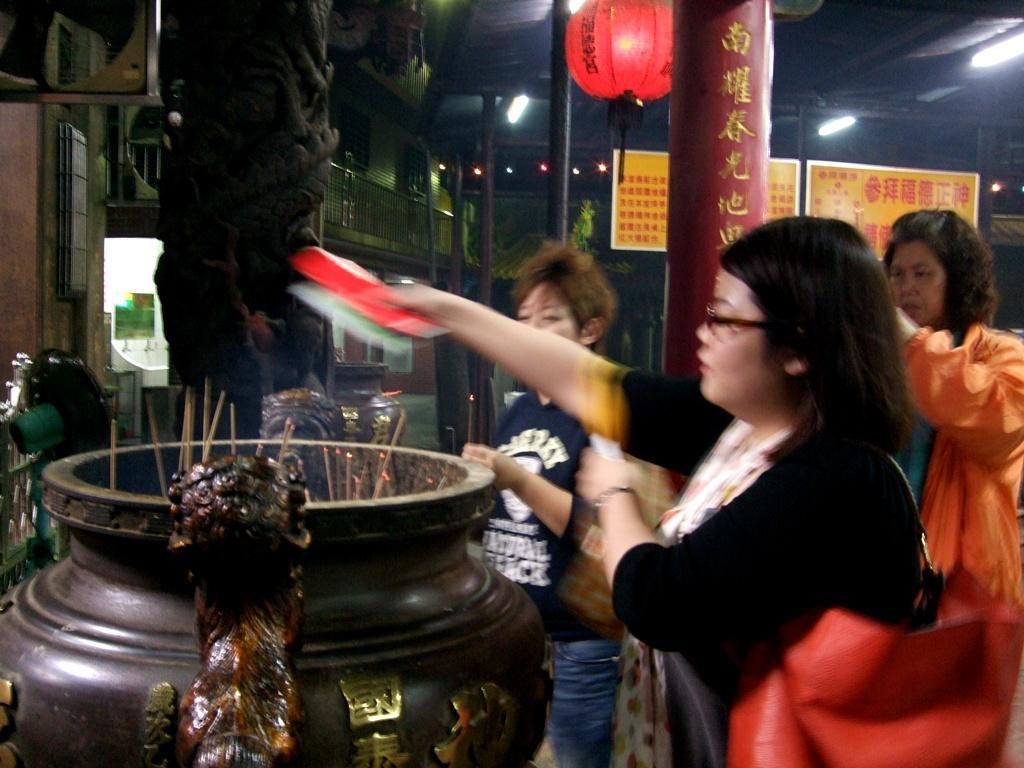Describe this image in one or two sentences. In this image we can see a group of people standing beside an antique. We can also see some sticks inside it and a woman holding a paper. On the backside we can see a building, some lights, poles, the boards with some text on it and some ceiling lights. 